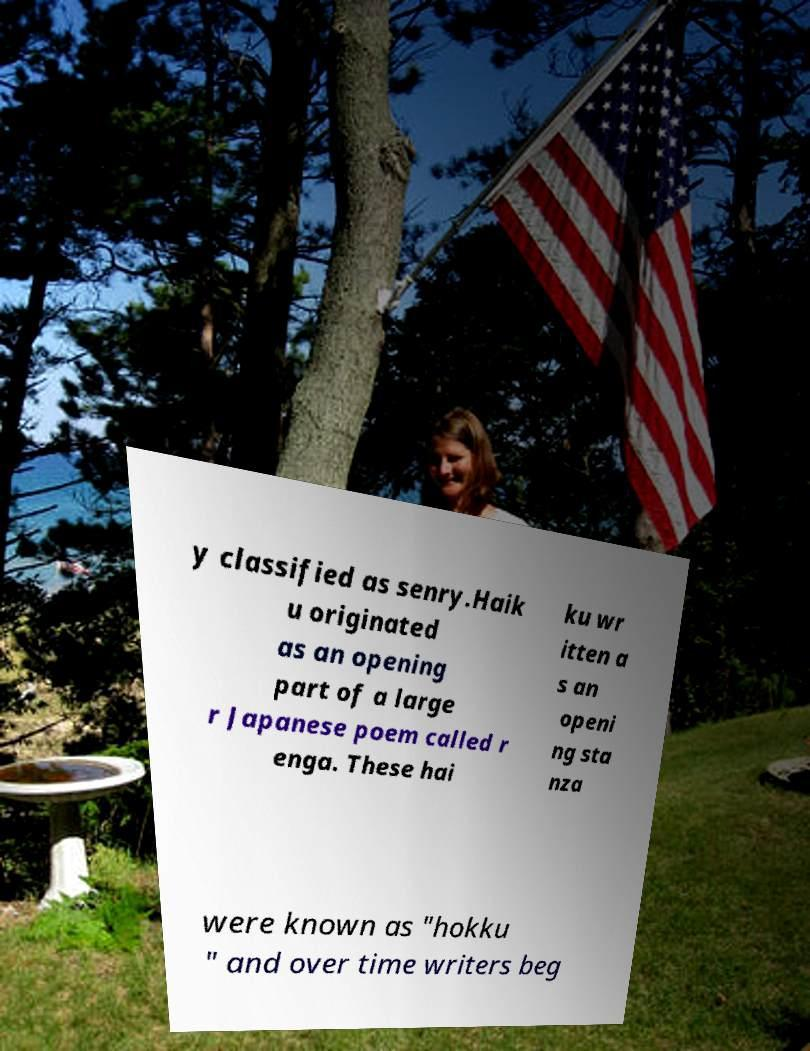What messages or text are displayed in this image? I need them in a readable, typed format. y classified as senry.Haik u originated as an opening part of a large r Japanese poem called r enga. These hai ku wr itten a s an openi ng sta nza were known as "hokku " and over time writers beg 